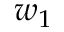Convert formula to latex. <formula><loc_0><loc_0><loc_500><loc_500>w _ { 1 }</formula> 